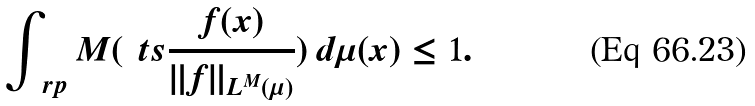<formula> <loc_0><loc_0><loc_500><loc_500>\int _ { \ r p } M ( \ t s \frac { f ( x ) } { \| f \| _ { L ^ { M } ( \mu ) } } ) \, d \mu ( x ) \leq 1 .</formula> 